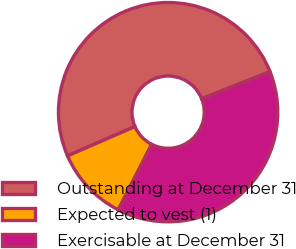<chart> <loc_0><loc_0><loc_500><loc_500><pie_chart><fcel>Outstanding at December 31<fcel>Expected to vest (1)<fcel>Exercisable at December 31<nl><fcel>50.51%<fcel>10.96%<fcel>38.53%<nl></chart> 